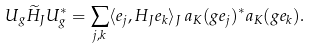<formula> <loc_0><loc_0><loc_500><loc_500>U _ { g } \widetilde { H } _ { J } U _ { g } ^ { * } = \sum _ { j , k } \langle e _ { j } , H _ { J } e _ { k } \rangle _ { J } \, a _ { K } ( g e _ { j } ) ^ { * } a _ { K } ( g e _ { k } ) .</formula> 